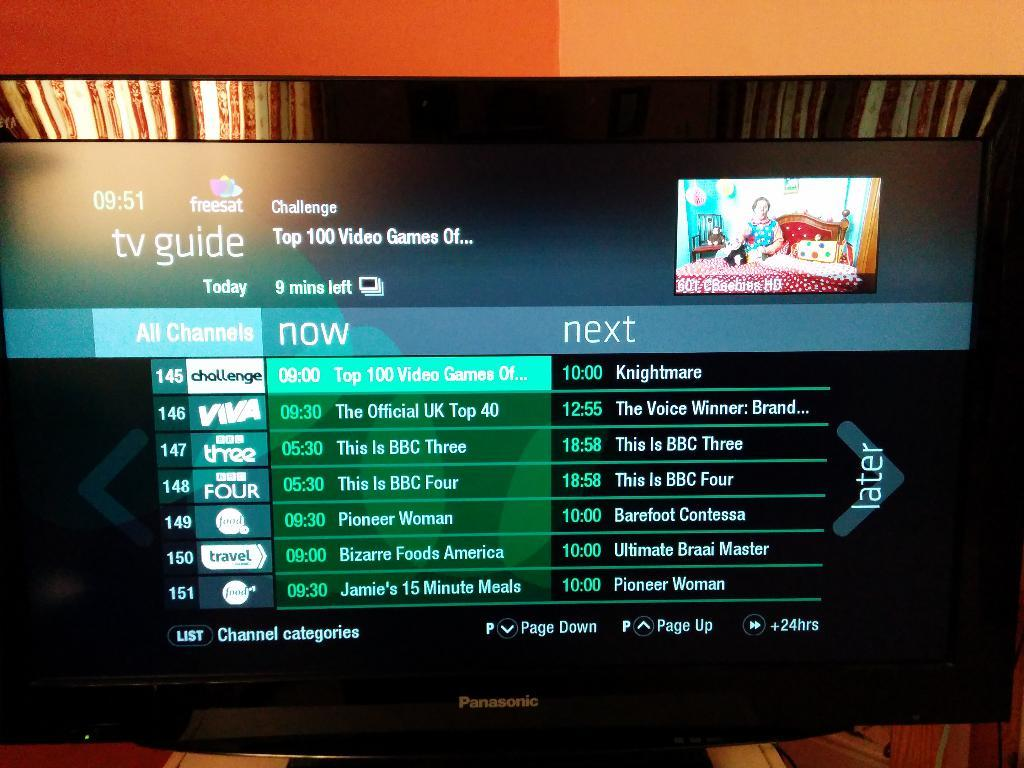<image>
Create a compact narrative representing the image presented. A tv guide is shown on a Panasonic television screen. 